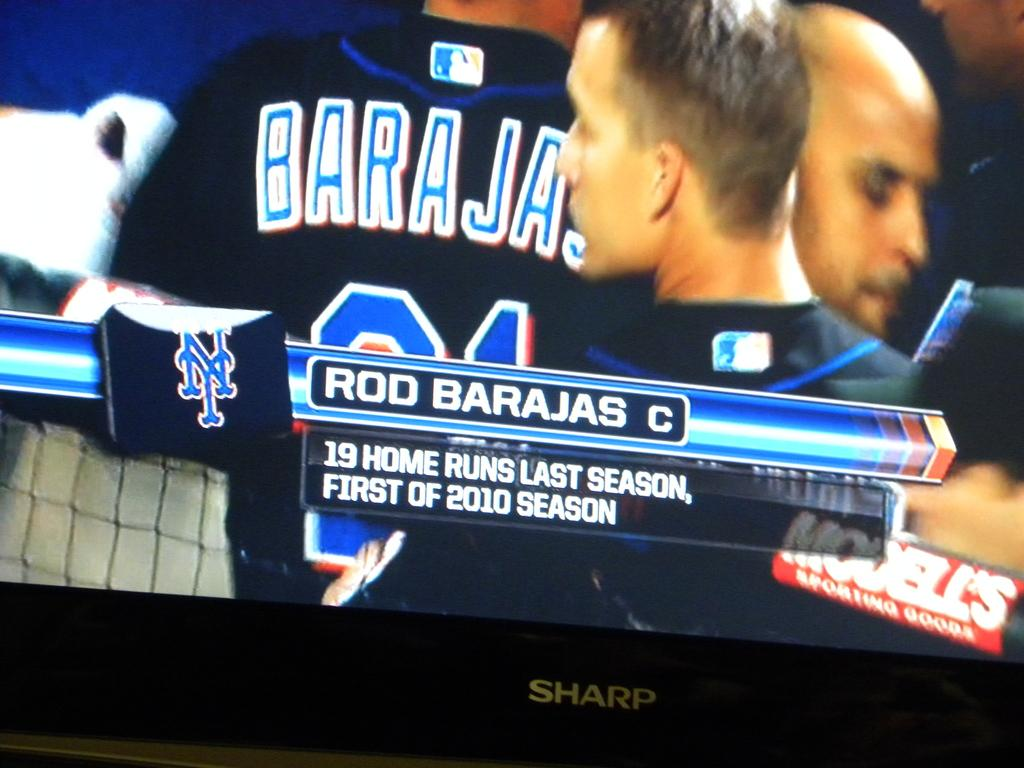<image>
Offer a succinct explanation of the picture presented. a catcher named Rod Barajas walking in the dugout 